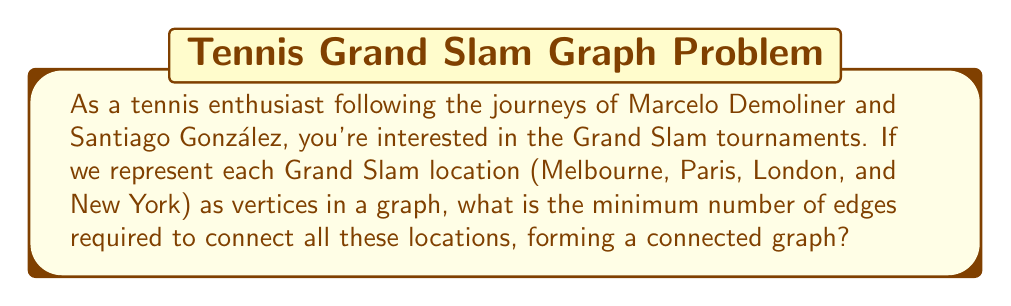Show me your answer to this math problem. To solve this problem, we can use the concept of a minimum spanning tree in graph theory. Here's the step-by-step explanation:

1) First, let's identify our vertices:
   - Melbourne (Australian Open)
   - Paris (French Open)
   - London (Wimbledon)
   - New York (US Open)

2) In graph theory, a tree is a connected graph with no cycles. A spanning tree of a graph is a tree that includes all the vertices of the graph.

3) The minimum number of edges required to connect $n$ vertices in a tree is always $n - 1$. This is because:
   - Each edge connects two vertices
   - To connect all vertices, we need to connect $n-1$ pairs
   - Adding any more edges would create a cycle, which is not allowed in a tree

4) In our case, we have 4 vertices (the four Grand Slam locations).

5) Therefore, the minimum number of edges required is:

   $$n - 1 = 4 - 1 = 3$$

This solution creates a spanning tree that connects all Grand Slam locations with the minimum possible number of connections, which could represent, for example, the most efficient way to travel between these tournaments.
Answer: 3 edges 